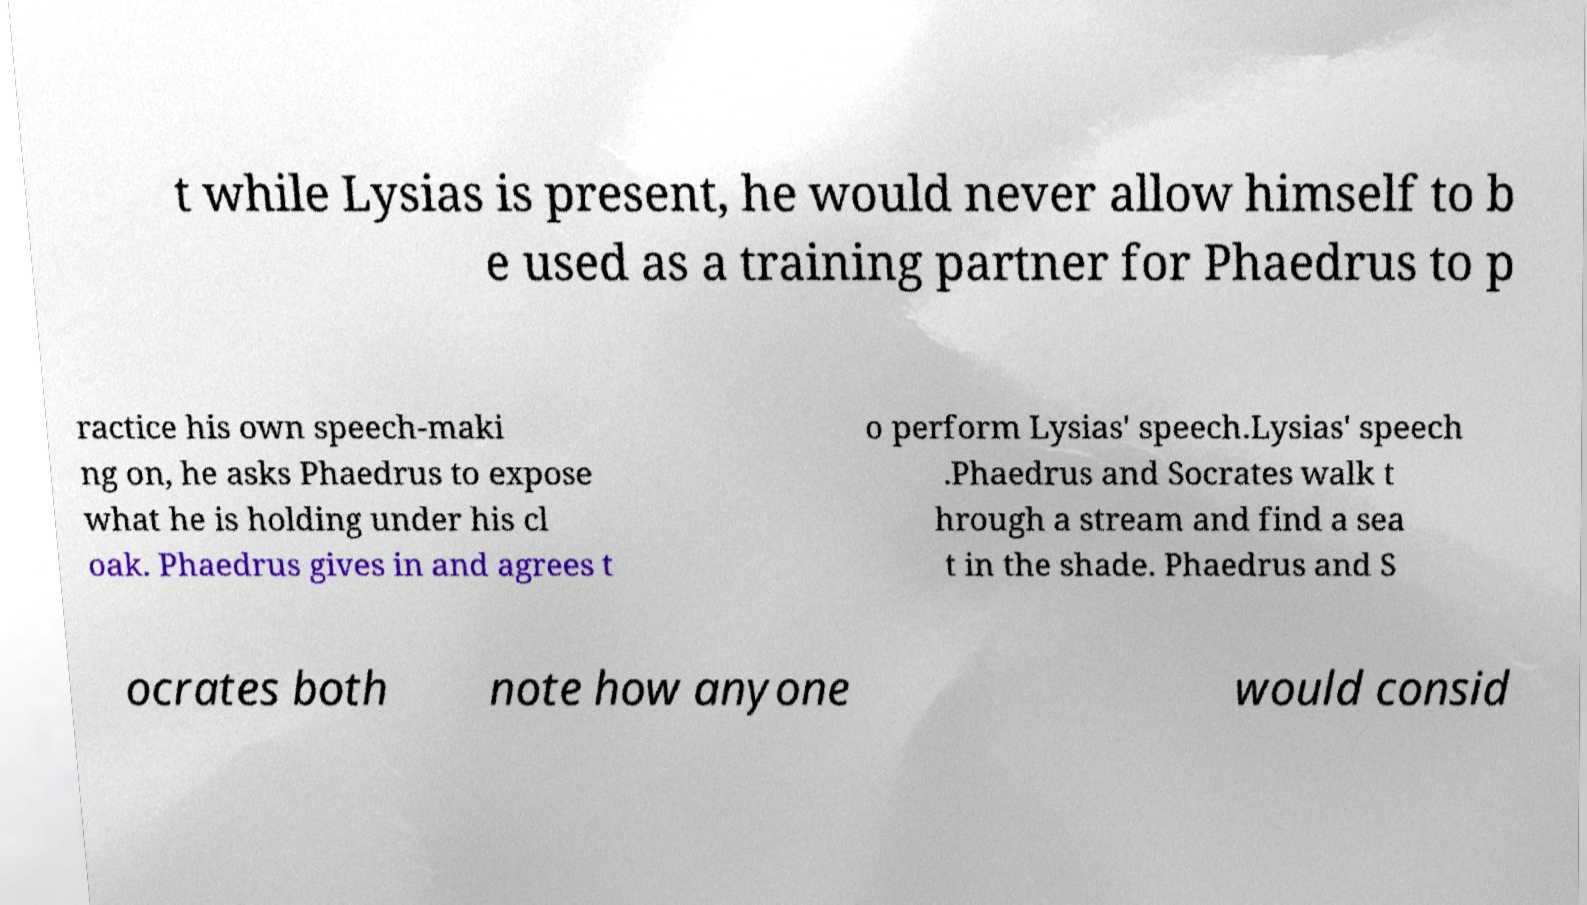Please identify and transcribe the text found in this image. t while Lysias is present, he would never allow himself to b e used as a training partner for Phaedrus to p ractice his own speech-maki ng on, he asks Phaedrus to expose what he is holding under his cl oak. Phaedrus gives in and agrees t o perform Lysias' speech.Lysias' speech .Phaedrus and Socrates walk t hrough a stream and find a sea t in the shade. Phaedrus and S ocrates both note how anyone would consid 